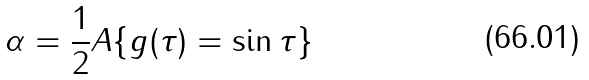<formula> <loc_0><loc_0><loc_500><loc_500>\alpha = \frac { 1 } { 2 } { A \{ g ( \tau ) = \sin \tau \} }</formula> 